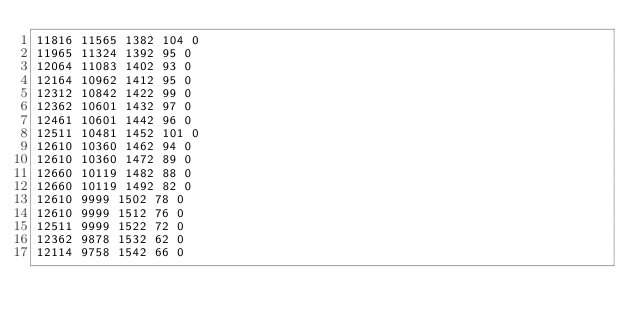Convert code to text. <code><loc_0><loc_0><loc_500><loc_500><_SML_>11816 11565 1382 104 0
11965 11324 1392 95 0
12064 11083 1402 93 0
12164 10962 1412 95 0
12312 10842 1422 99 0
12362 10601 1432 97 0
12461 10601 1442 96 0
12511 10481 1452 101 0
12610 10360 1462 94 0
12610 10360 1472 89 0
12660 10119 1482 88 0
12660 10119 1492 82 0
12610 9999 1502 78 0
12610 9999 1512 76 0
12511 9999 1522 72 0
12362 9878 1532 62 0
12114 9758 1542 66 0</code> 